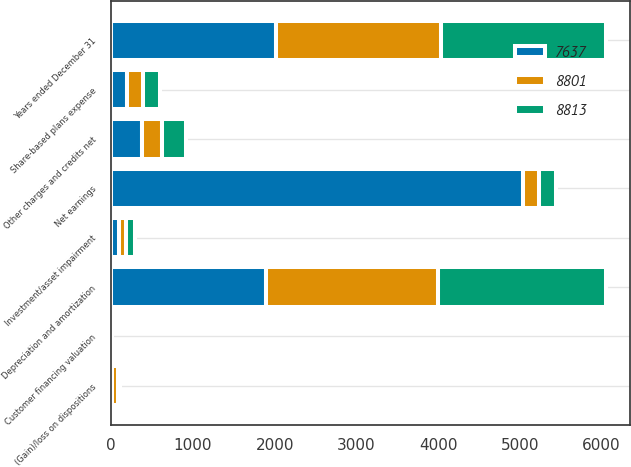Convert chart to OTSL. <chart><loc_0><loc_0><loc_500><loc_500><stacked_bar_chart><ecel><fcel>Years ended December 31<fcel>Net earnings<fcel>Share-based plans expense<fcel>Depreciation and amortization<fcel>Investment/asset impairment<fcel>Customer financing valuation<fcel>(Gain)/loss on dispositions<fcel>Other charges and credits net<nl><fcel>8801<fcel>2018<fcel>202<fcel>202<fcel>2114<fcel>93<fcel>3<fcel>75<fcel>247<nl><fcel>8813<fcel>2017<fcel>202<fcel>202<fcel>2047<fcel>113<fcel>2<fcel>21<fcel>293<nl><fcel>7637<fcel>2016<fcel>5034<fcel>190<fcel>1889<fcel>90<fcel>7<fcel>7<fcel>371<nl></chart> 